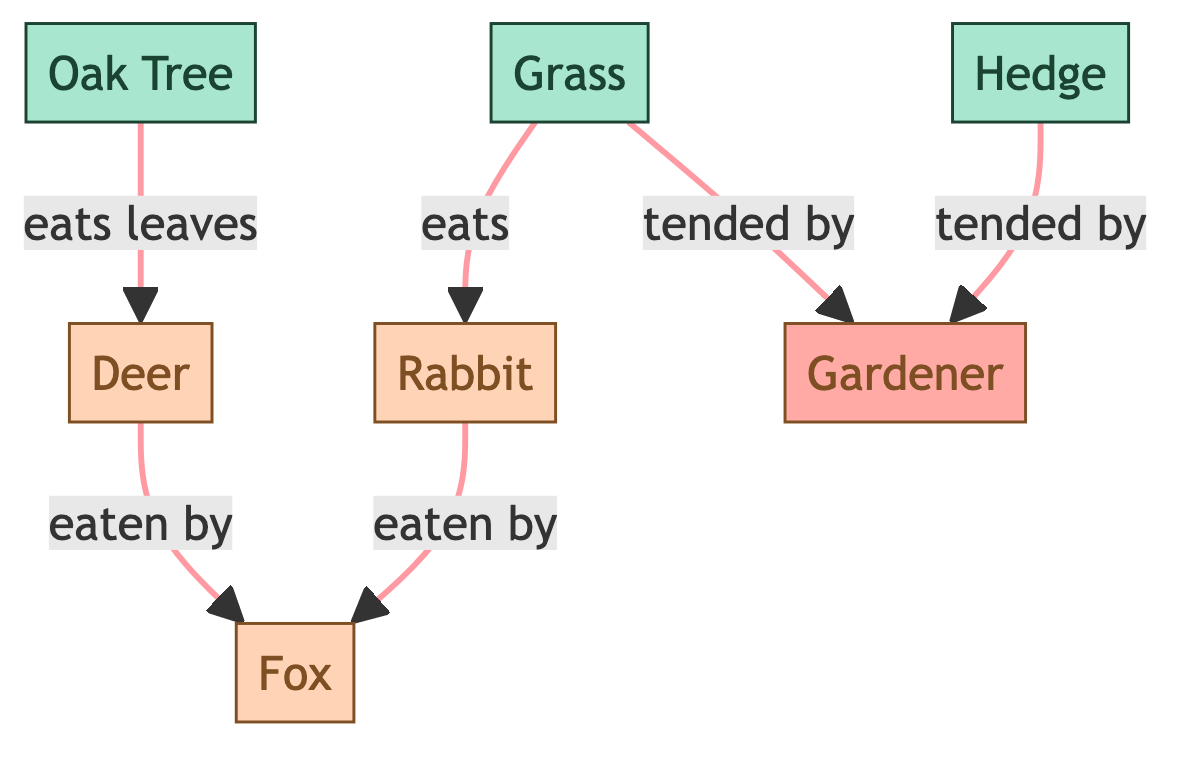What animal eats grass? In the diagram, the arrow indicates that grass is consumed by the rabbit. Therefore, the rabbit is the animal that eats grass.
Answer: rabbit What plant is eaten by the deer? The arrow shows that the deer eats leaves from the oak tree. Hence, the plant consumed by the deer is the oak tree.
Answer: oak tree How many animals are present in the food chain? The diagram includes three animals: rabbit, fox, and deer. Therefore, the total count of animals is three.
Answer: 3 Which human tends to the hedge? The diagram states that the gardener is responsible for tending the hedge. Hence, the gardener is the human associated with the hedge.
Answer: gardener What is the relationship between the fox and the rabbit? The arrow indicates that the rabbit is eaten by the fox, establishing a predator-prey relationship where the fox consumes the rabbit.
Answer: eaten by How many total nodes are in the diagram? By counting all distinct entities, we have six nodes: oak tree, grass, hedge, rabbit, fox, deer, and gardener. This totals to seven nodes.
Answer: 7 Which plant is tended by the gardener in addition to grass? The diagram tells us that the gardener tends both grass and hedge. So, the plant that is also tended by the gardener is the hedge.
Answer: hedge Between which two animals does the fox occupy a predator role? From the arrows, the fox preys on the rabbit and the deer. Therefore, the two animals where the fox acts as a predator are the rabbit and the deer.
Answer: rabbit and deer What is the primary food source for the fox? The arrows indicate that the fox preys on both the rabbit and the deer. Thus, the main food sources for the fox are these two animals.
Answer: rabbit and deer 